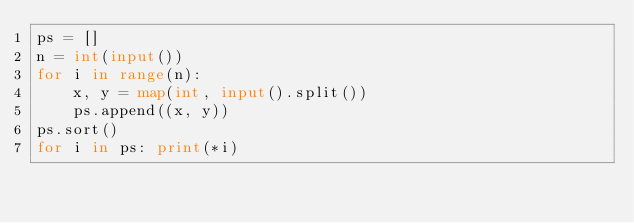<code> <loc_0><loc_0><loc_500><loc_500><_Python_>ps = []
n = int(input())
for i in range(n):
    x, y = map(int, input().split())
    ps.append((x, y))
ps.sort()
for i in ps: print(*i)
</code> 